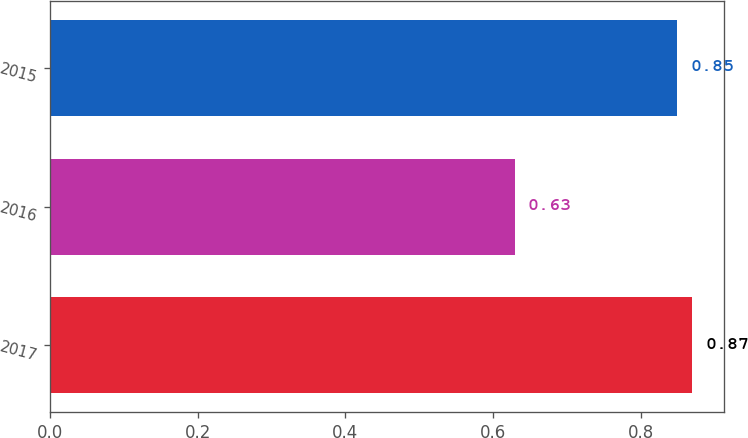Convert chart. <chart><loc_0><loc_0><loc_500><loc_500><bar_chart><fcel>2017<fcel>2016<fcel>2015<nl><fcel>0.87<fcel>0.63<fcel>0.85<nl></chart> 